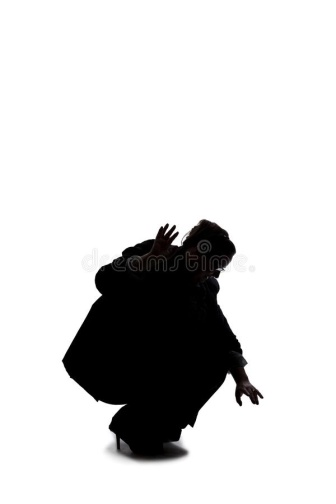Could this image represent an emotion? Which one and why? This image could represent the emotion of fear or anticipation. The crouched position and the outstretched, claw-like hands convey a sense of readiness and wariness, as if the person is bracing themselves for something imminent. The stark contrast between the black silhouette and the white background amplifies the tension, highlighting an emotional state of high alert or intense focus. Describe a scenario where this pose might be necessary. This pose might be necessary in a survival situation, where the individual is preparing to defend themselves against a threat. Imagine a post-apocalyptic world where every shadow hides danger; the person must stay low, ready to react at a moment's notice to any potential threat. The posture suggests both readiness to strike and an attempt to remain unnoticed until the last possible moment. 